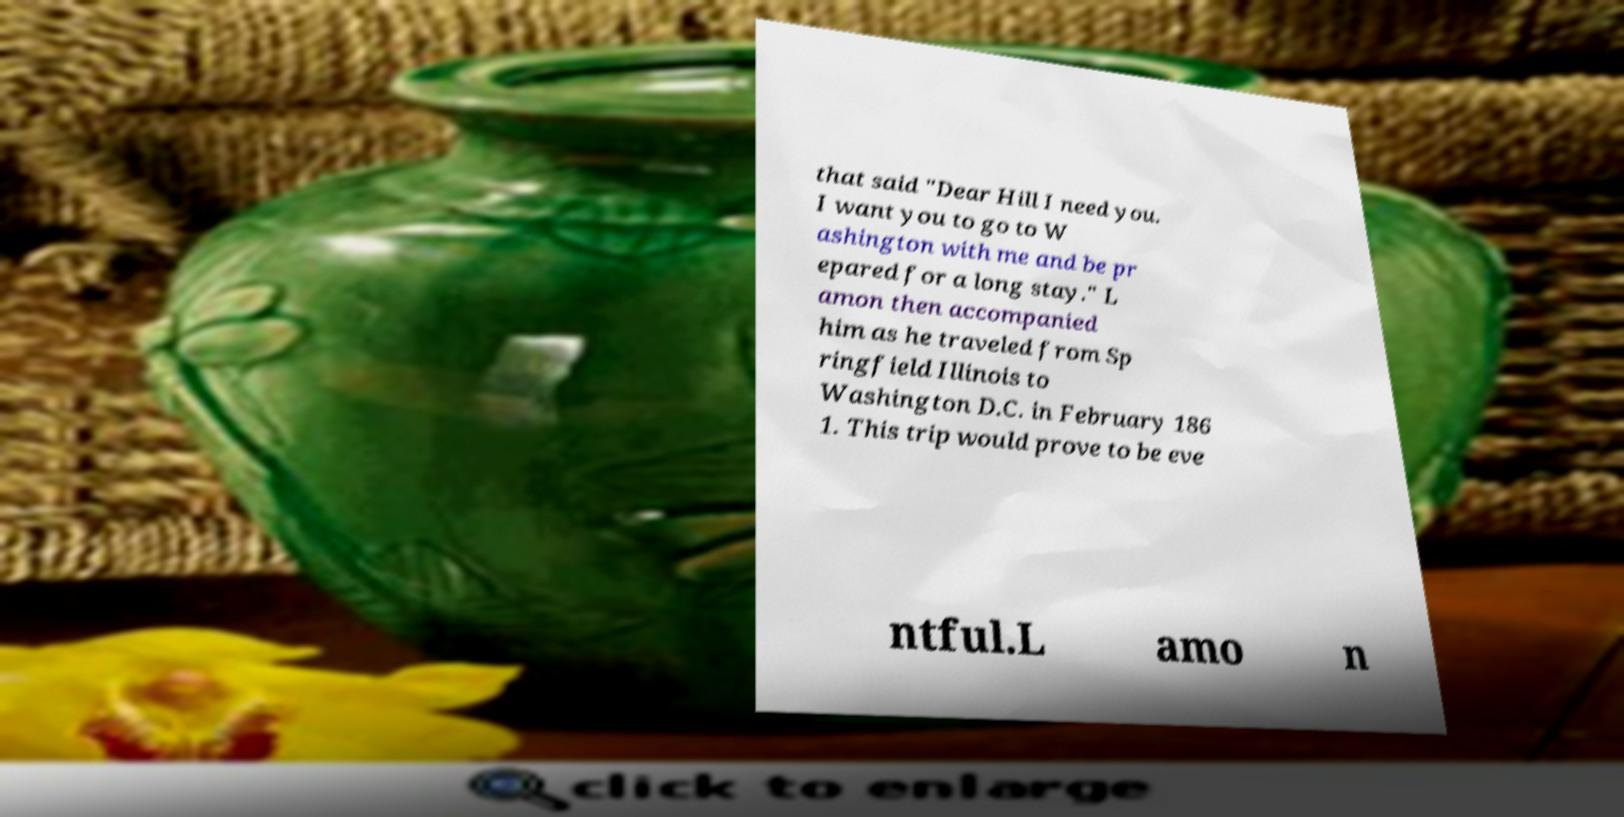Could you extract and type out the text from this image? that said "Dear Hill I need you. I want you to go to W ashington with me and be pr epared for a long stay." L amon then accompanied him as he traveled from Sp ringfield Illinois to Washington D.C. in February 186 1. This trip would prove to be eve ntful.L amo n 